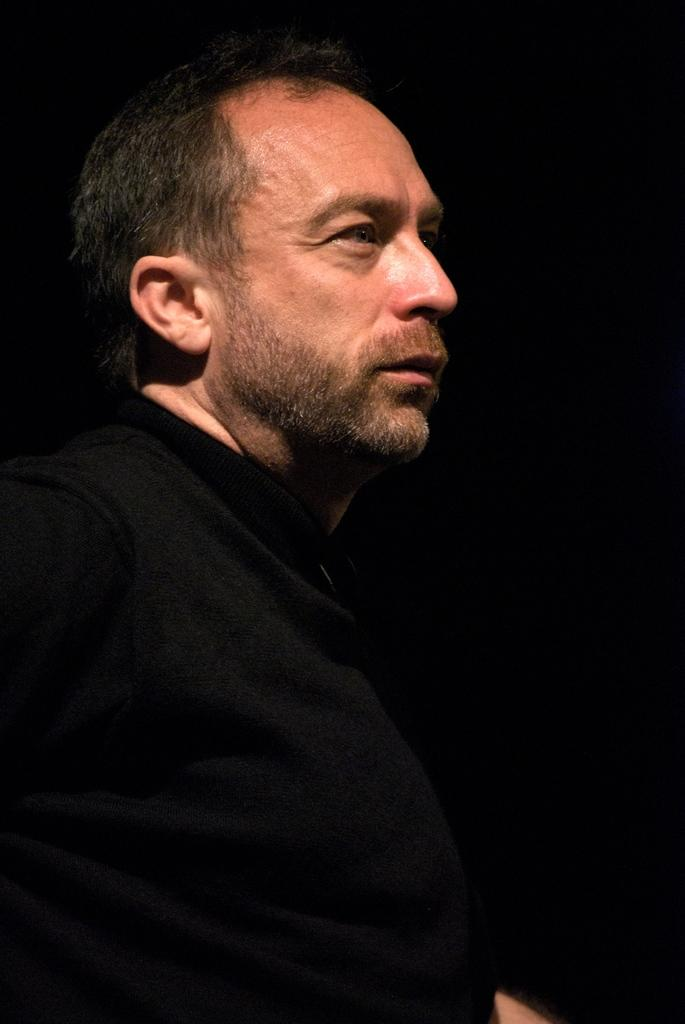Who is present in the image? There is a man in the image. What is the man wearing in the image? The man is wearing a black t-shirt in the image. What can be seen behind the man in the image? There is a dark background in the image. Where is the nest located in the image? There is no nest present in the image. What type of tent is visible in the image? There is no tent present in the image. 